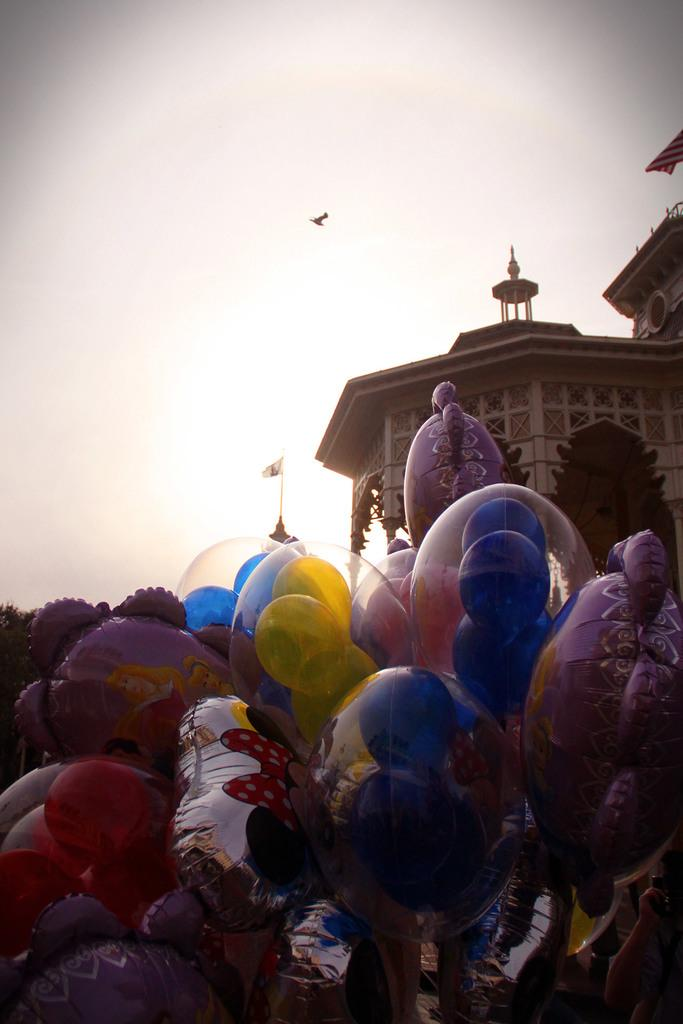What is the main subject of the image? There is a group of toys in the image. What can be seen on the right side of the image? There is a building on the right side of the image. What is the object with a specific design and colors in the image? There is a flag in the image. What is flying in the sky in the image? There is a bird flying in the sky. What type of leather material can be seen on the toys in the image? There is no leather material present on the toys in the image. Can you tell me how many donkeys are in the image? There are no donkeys present in the image. 